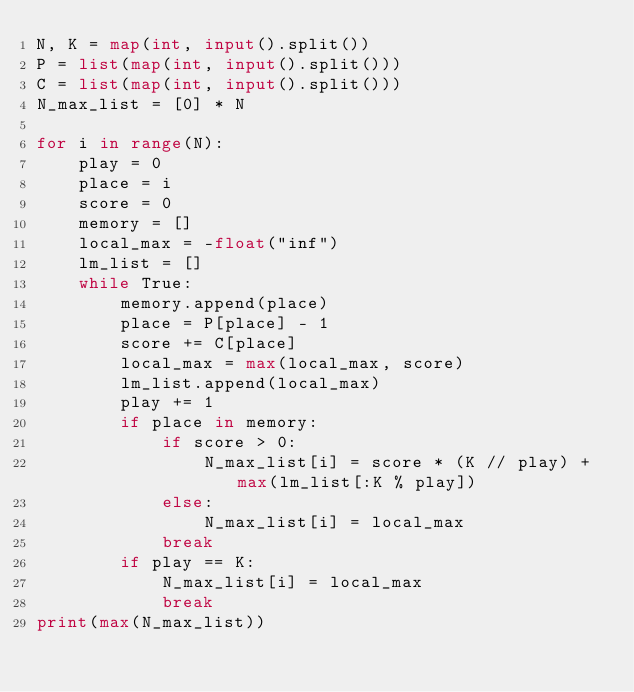Convert code to text. <code><loc_0><loc_0><loc_500><loc_500><_Python_>N, K = map(int, input().split())
P = list(map(int, input().split()))
C = list(map(int, input().split()))
N_max_list = [0] * N

for i in range(N):
    play = 0
    place = i
    score = 0
    memory = []
    local_max = -float("inf")
    lm_list = []
    while True:
        memory.append(place)
        place = P[place] - 1
        score += C[place]
        local_max = max(local_max, score)
        lm_list.append(local_max)
        play += 1
        if place in memory:
            if score > 0:
                N_max_list[i] = score * (K // play) + max(lm_list[:K % play])
            else:
                N_max_list[i] = local_max
            break
        if play == K:
            N_max_list[i] = local_max
            break
print(max(N_max_list))
</code> 